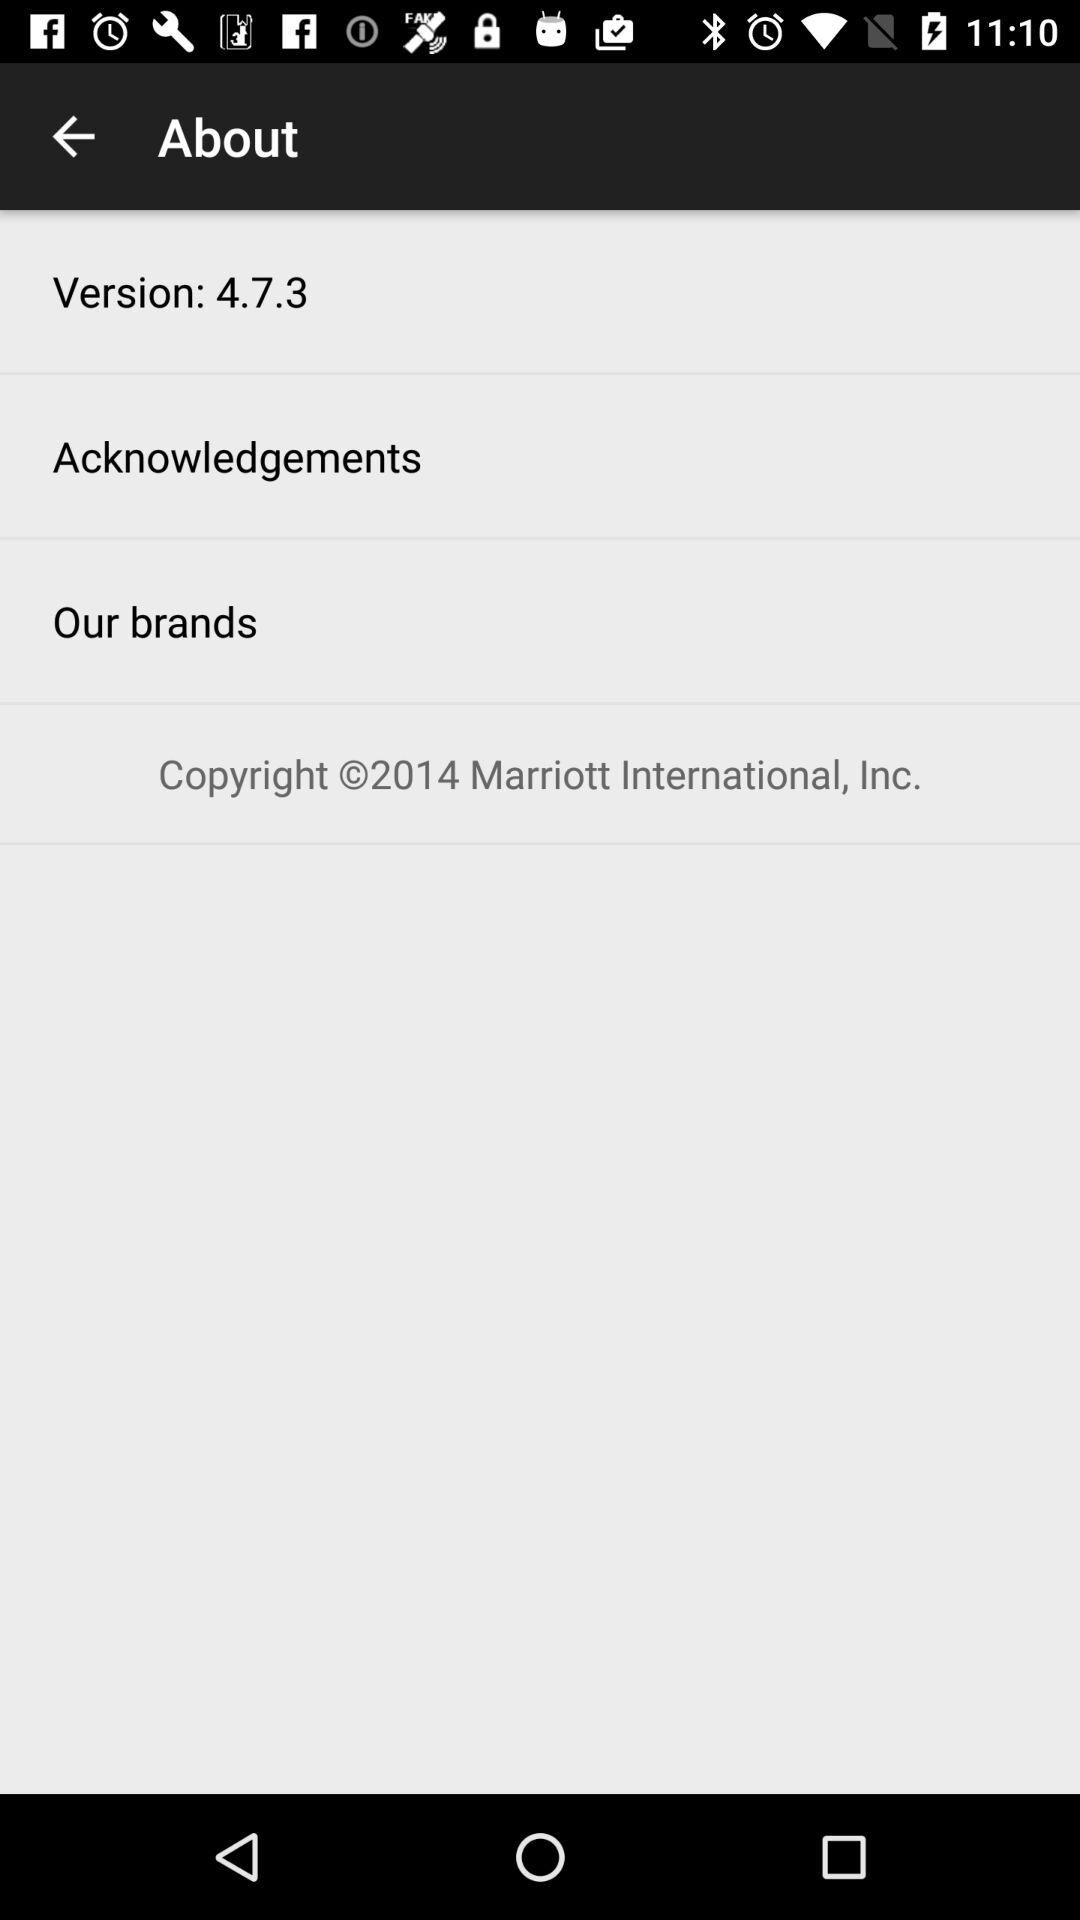Which version of the application is used? The used version is 4.7.3. 